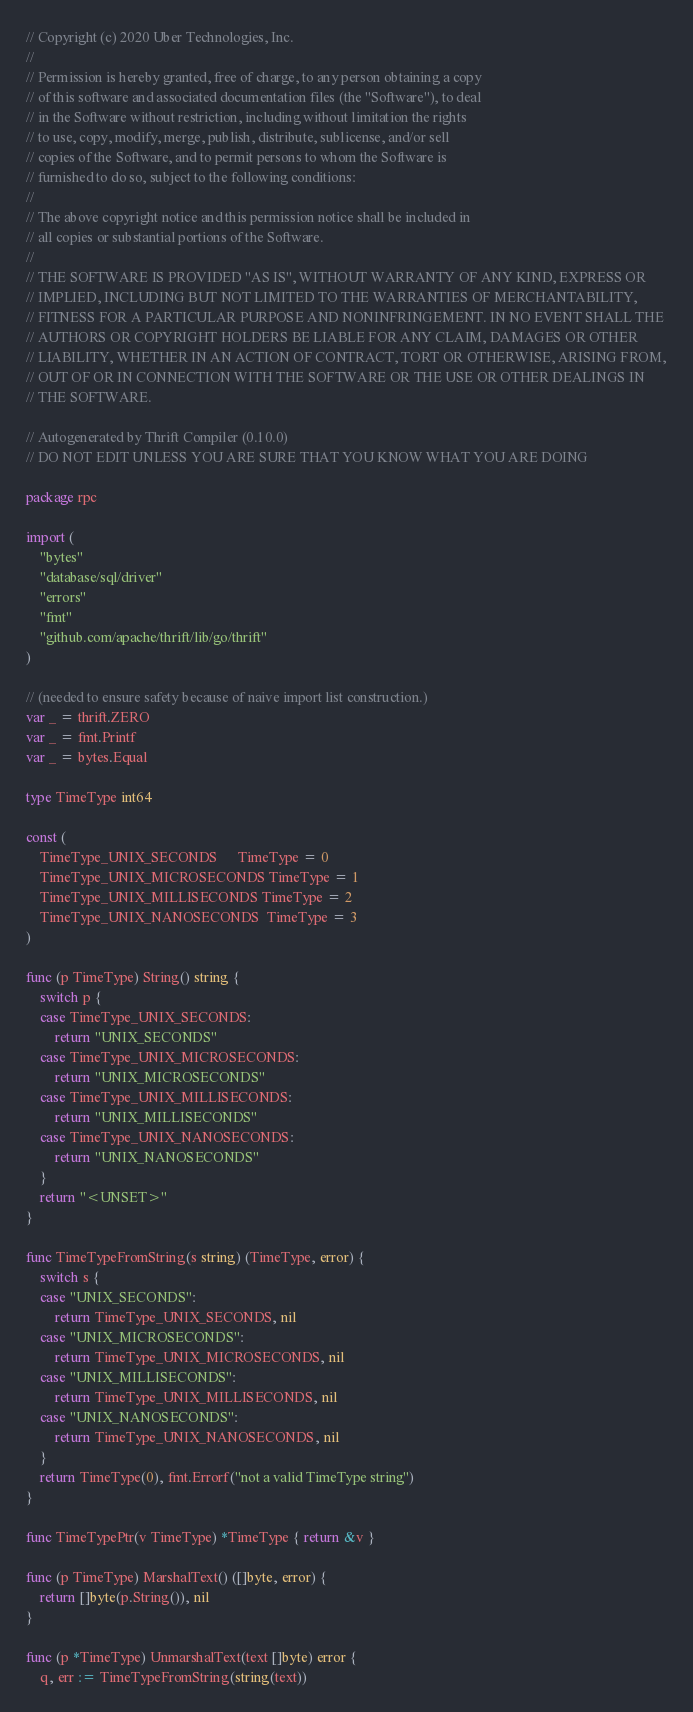Convert code to text. <code><loc_0><loc_0><loc_500><loc_500><_Go_>// Copyright (c) 2020 Uber Technologies, Inc.
//
// Permission is hereby granted, free of charge, to any person obtaining a copy
// of this software and associated documentation files (the "Software"), to deal
// in the Software without restriction, including without limitation the rights
// to use, copy, modify, merge, publish, distribute, sublicense, and/or sell
// copies of the Software, and to permit persons to whom the Software is
// furnished to do so, subject to the following conditions:
//
// The above copyright notice and this permission notice shall be included in
// all copies or substantial portions of the Software.
//
// THE SOFTWARE IS PROVIDED "AS IS", WITHOUT WARRANTY OF ANY KIND, EXPRESS OR
// IMPLIED, INCLUDING BUT NOT LIMITED TO THE WARRANTIES OF MERCHANTABILITY,
// FITNESS FOR A PARTICULAR PURPOSE AND NONINFRINGEMENT. IN NO EVENT SHALL THE
// AUTHORS OR COPYRIGHT HOLDERS BE LIABLE FOR ANY CLAIM, DAMAGES OR OTHER
// LIABILITY, WHETHER IN AN ACTION OF CONTRACT, TORT OR OTHERWISE, ARISING FROM,
// OUT OF OR IN CONNECTION WITH THE SOFTWARE OR THE USE OR OTHER DEALINGS IN
// THE SOFTWARE.

// Autogenerated by Thrift Compiler (0.10.0)
// DO NOT EDIT UNLESS YOU ARE SURE THAT YOU KNOW WHAT YOU ARE DOING

package rpc

import (
	"bytes"
	"database/sql/driver"
	"errors"
	"fmt"
	"github.com/apache/thrift/lib/go/thrift"
)

// (needed to ensure safety because of naive import list construction.)
var _ = thrift.ZERO
var _ = fmt.Printf
var _ = bytes.Equal

type TimeType int64

const (
	TimeType_UNIX_SECONDS      TimeType = 0
	TimeType_UNIX_MICROSECONDS TimeType = 1
	TimeType_UNIX_MILLISECONDS TimeType = 2
	TimeType_UNIX_NANOSECONDS  TimeType = 3
)

func (p TimeType) String() string {
	switch p {
	case TimeType_UNIX_SECONDS:
		return "UNIX_SECONDS"
	case TimeType_UNIX_MICROSECONDS:
		return "UNIX_MICROSECONDS"
	case TimeType_UNIX_MILLISECONDS:
		return "UNIX_MILLISECONDS"
	case TimeType_UNIX_NANOSECONDS:
		return "UNIX_NANOSECONDS"
	}
	return "<UNSET>"
}

func TimeTypeFromString(s string) (TimeType, error) {
	switch s {
	case "UNIX_SECONDS":
		return TimeType_UNIX_SECONDS, nil
	case "UNIX_MICROSECONDS":
		return TimeType_UNIX_MICROSECONDS, nil
	case "UNIX_MILLISECONDS":
		return TimeType_UNIX_MILLISECONDS, nil
	case "UNIX_NANOSECONDS":
		return TimeType_UNIX_NANOSECONDS, nil
	}
	return TimeType(0), fmt.Errorf("not a valid TimeType string")
}

func TimeTypePtr(v TimeType) *TimeType { return &v }

func (p TimeType) MarshalText() ([]byte, error) {
	return []byte(p.String()), nil
}

func (p *TimeType) UnmarshalText(text []byte) error {
	q, err := TimeTypeFromString(string(text))</code> 